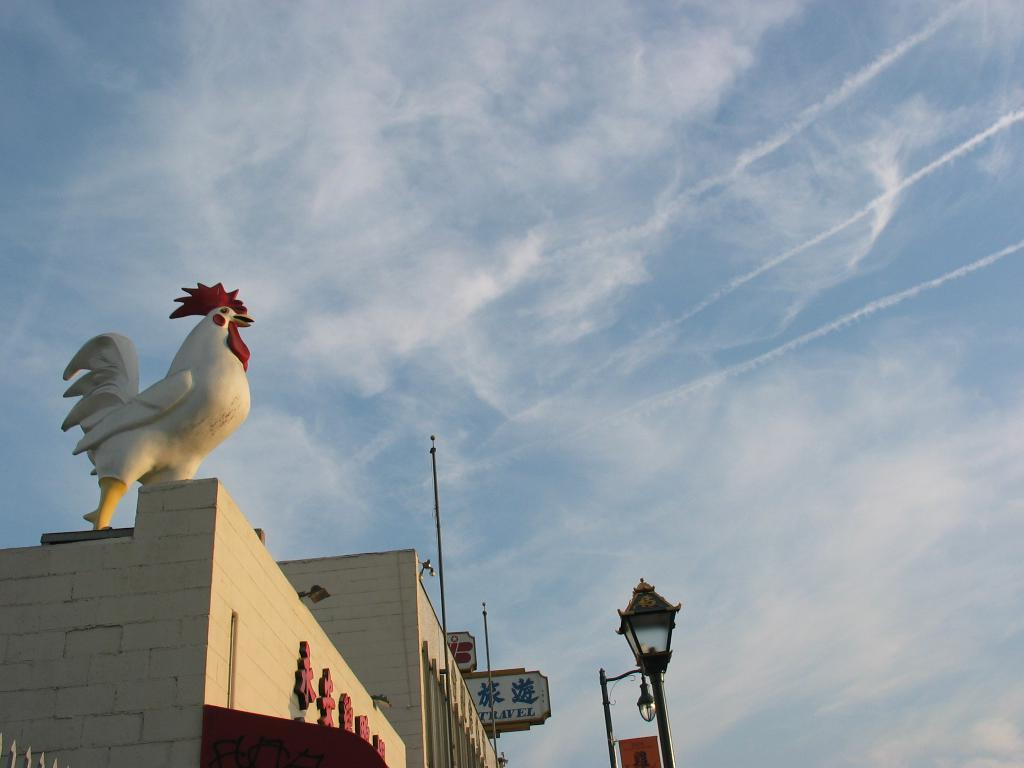What is on top of the building in the image? There is a statue of a hen on top of the building. What can be seen in front of the building? There is a lamp post in front of the building. What verse is being recited by the statue of the hen in the image? There is no indication that the statue of the hen is reciting a verse, as it is a statue and not a living being. 